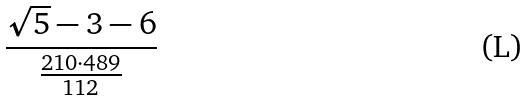Convert formula to latex. <formula><loc_0><loc_0><loc_500><loc_500>\frac { \sqrt { 5 } - 3 - 6 } { \frac { 2 1 0 \cdot 4 8 9 } { 1 1 2 } }</formula> 